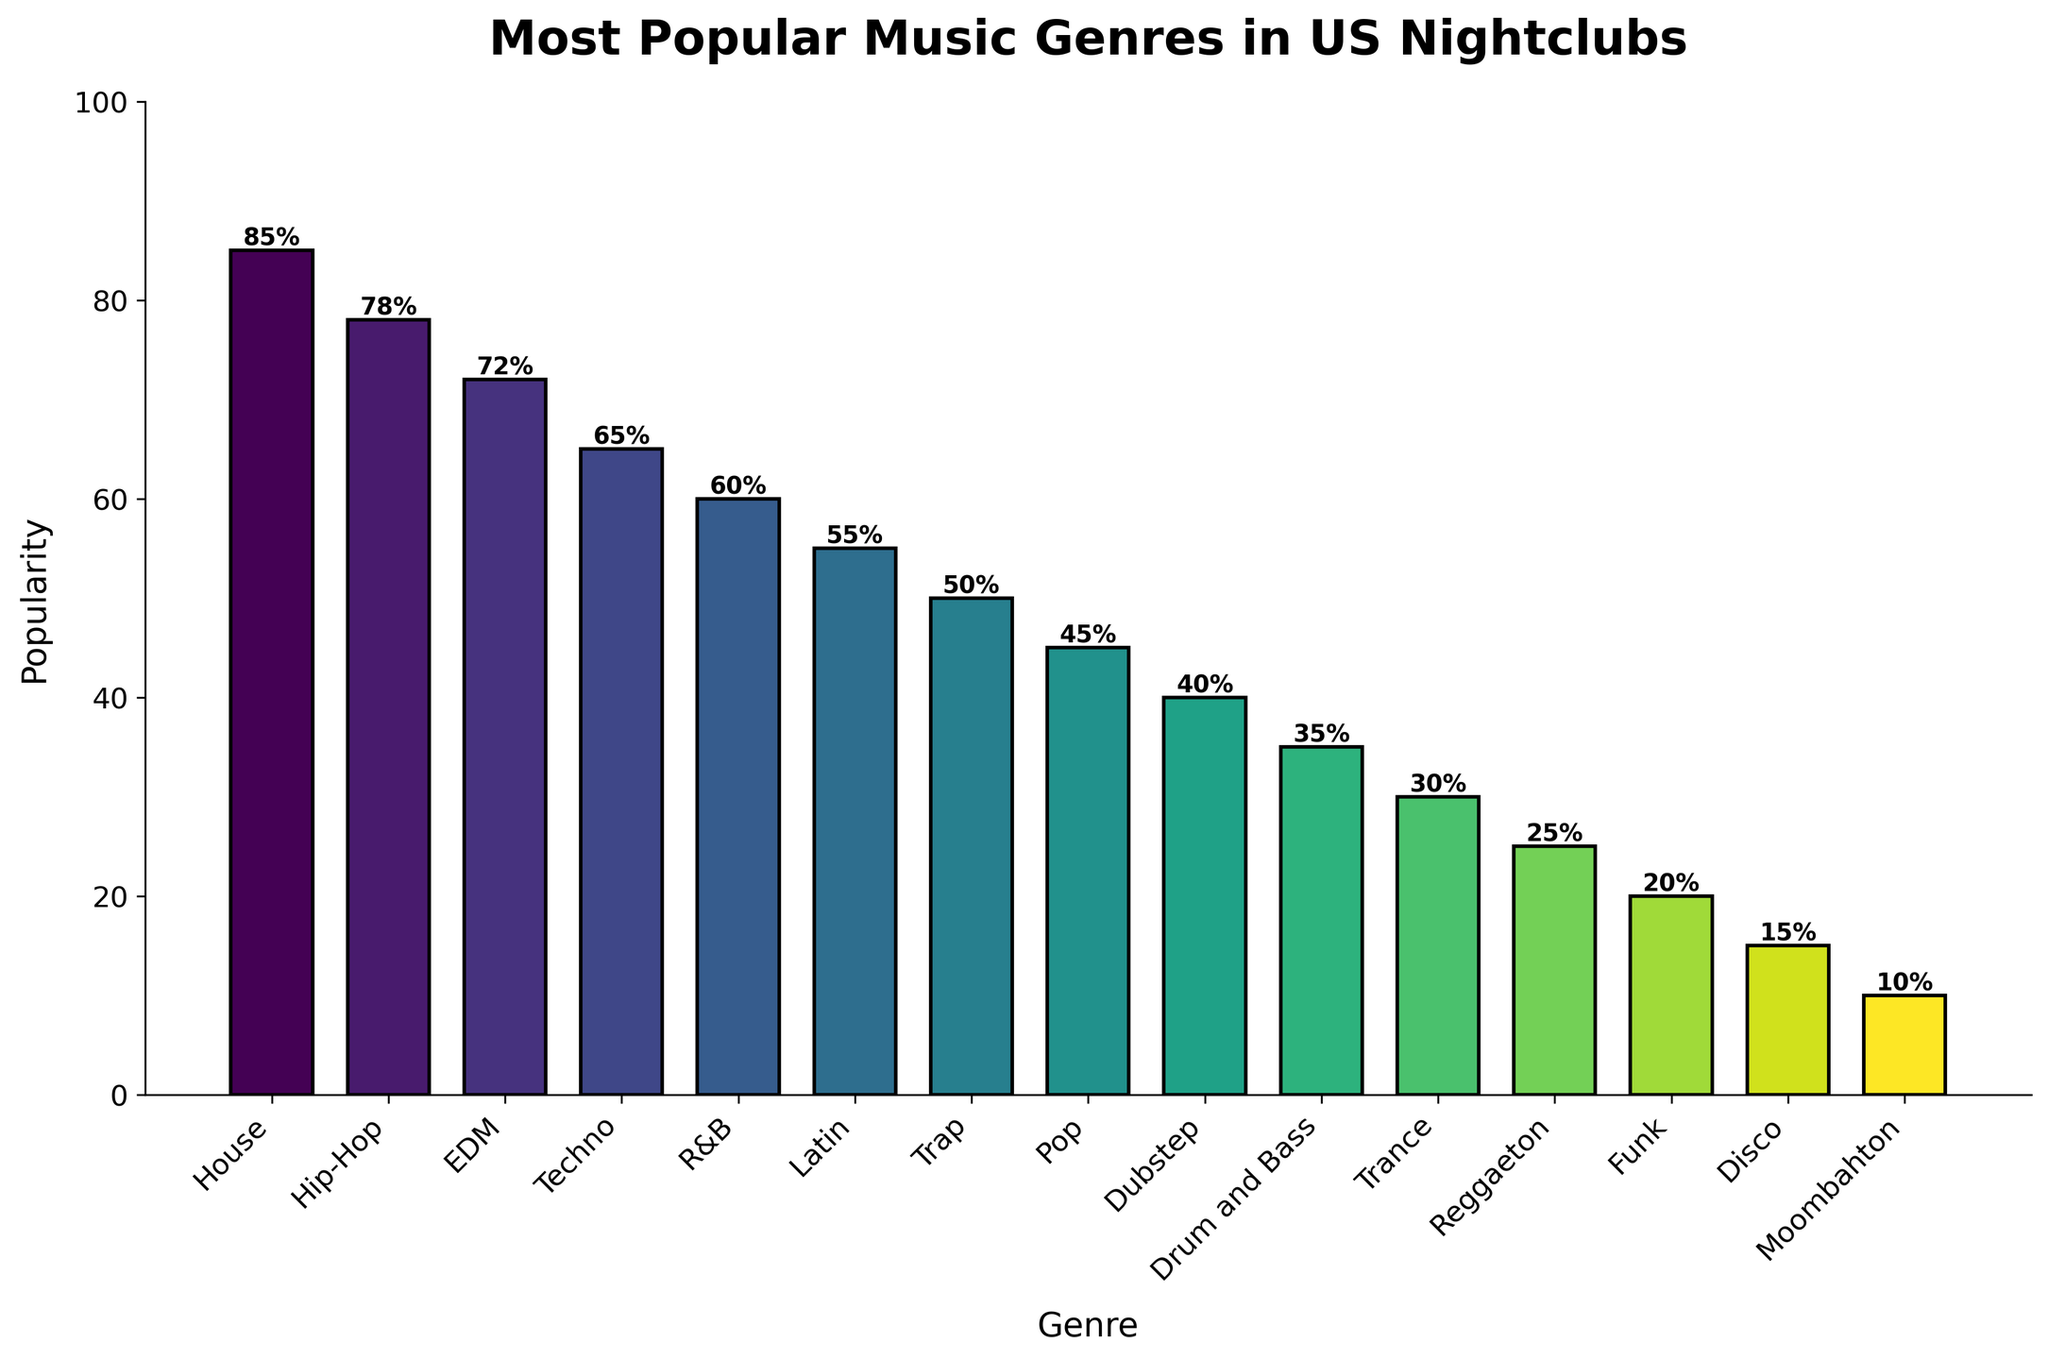Which genre is the most popular in US nightclubs? The bar for 'House' has the highest height among all the bars on the chart.
Answer: House What is the popularity difference between House and Hip-Hop? House has a popularity of 85%, and Hip-Hop has a popularity of 78%. The difference is 85% - 78%.
Answer: 7% Which genre is the least popular in US nightclubs? The bar for 'Moombahton' has the lowest height among all the bars on the chart.
Answer: Moombahton How many genres have a popularity of 50% or higher? The genres with popularity 50% or higher are House, Hip-Hop, EDM, Techno, R&B, and Latin, making the total count 6.
Answer: 6 What is the aggregate popularity of Techno, R&B, and Latin? Sum the popularity values for Techno (65%), R&B (60%), and Latin (55%). The aggregate is 65% + 60% + 55%.
Answer: 180% How does the popularity of Pop compare to that of Trap? Pop has a popularity of 45%, while Trap has a popularity of 50%. Thus, Pop is less popular than Trap.
Answer: Pop is less popular than Trap What is the median popularity value of all the genres? First, list the popularity values in ascending order: [10, 15, 20, 25, 30, 35, 40, 45, 50, 55, 60, 65, 72, 78, 85]. The middle value is the 8th value in the sorted order (45%).
Answer: 45% Which genres have a higher popularity than EDM? EDM has a popularity of 72%. The genres with higher popularity are House (85%) and Hip-Hop (78%).
Answer: House, Hip-Hop What is the average popularity of the top 5 most popular genres? The top 5 genres are House (85%), Hip-Hop (78%), EDM (72%), Techno (65%), and R&B (60%). The sum is 85% + 78% + 72% + 65% + 60% = 360%. The average is 360% / 5.
Answer: 72% What color are the bars for Dubstep and Drum and Bass? Observing the bar colors on the chart, the bars gradually change color from top to bottom. The bars for Dubstep and Drum and Bass have a darker shade compared to those at the top of the list, likely indicating a greenish or dark green color.
Answer: Dark green 